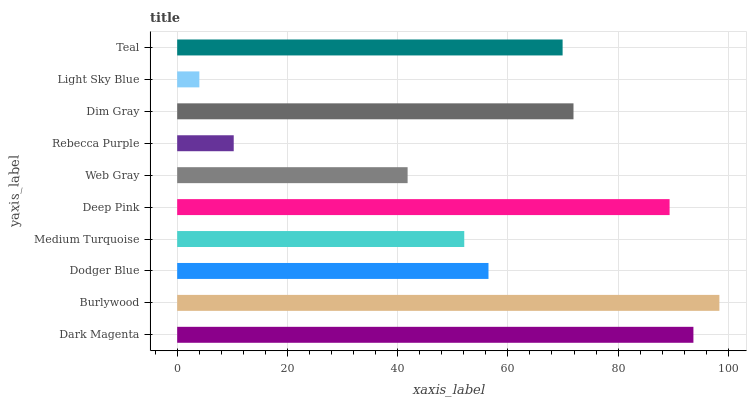Is Light Sky Blue the minimum?
Answer yes or no. Yes. Is Burlywood the maximum?
Answer yes or no. Yes. Is Dodger Blue the minimum?
Answer yes or no. No. Is Dodger Blue the maximum?
Answer yes or no. No. Is Burlywood greater than Dodger Blue?
Answer yes or no. Yes. Is Dodger Blue less than Burlywood?
Answer yes or no. Yes. Is Dodger Blue greater than Burlywood?
Answer yes or no. No. Is Burlywood less than Dodger Blue?
Answer yes or no. No. Is Teal the high median?
Answer yes or no. Yes. Is Dodger Blue the low median?
Answer yes or no. Yes. Is Deep Pink the high median?
Answer yes or no. No. Is Web Gray the low median?
Answer yes or no. No. 